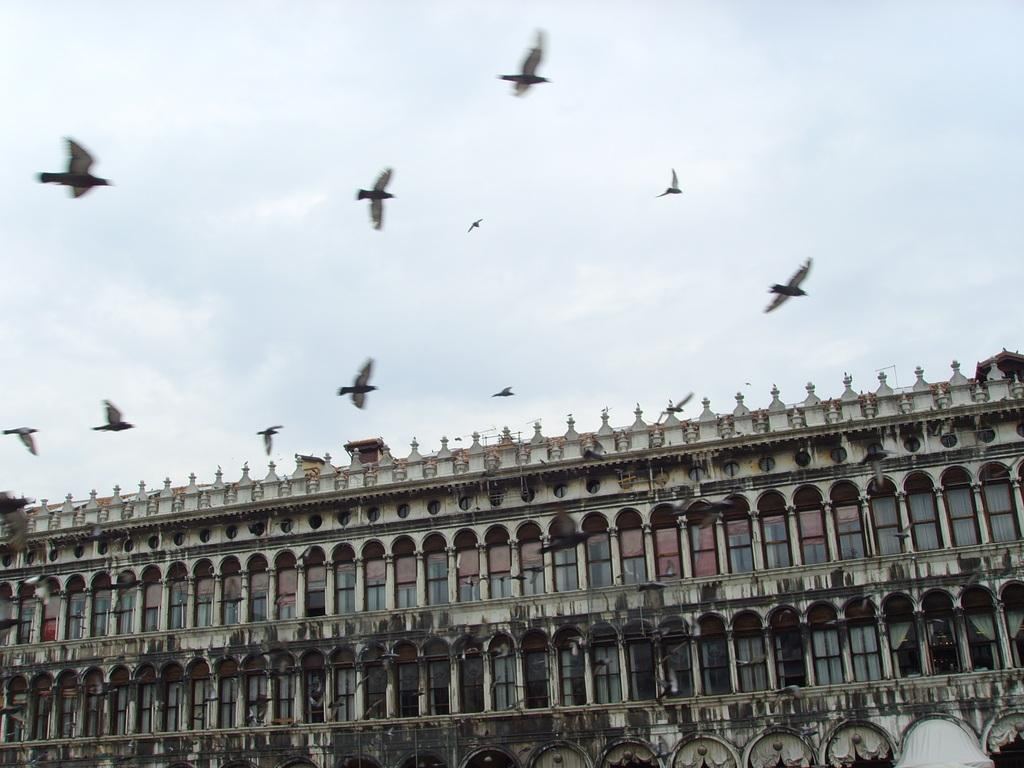What type of structure is visible in the image? There is a building in the image. What can be seen in the sky in the image? There are birds in the sky in the image. What type of knife does the carpenter use to cut the building in the image? There is no carpenter or knife present in the image. The building and birds are the only subjects visible. 